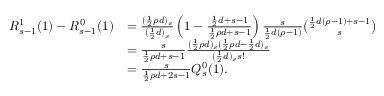Convert formula to latex. <formula><loc_0><loc_0><loc_500><loc_500>\begin{array} { r l } { R _ { s - 1 } ^ { 1 } ( 1 ) - R _ { s - 1 } ^ { 0 } ( 1 ) } & { = \frac { ( \frac { 1 } { 2 } \rho d ) _ { s } } { ( \frac { 1 } { 2 } d ) _ { s } } \left ( 1 - \frac { \frac { 1 } { 2 } d + s - 1 } { \frac { 1 } { 2 } \rho d + s - 1 } \right ) \frac { s } { \frac { 1 } { 2 } d ( \rho - 1 ) } \binom { \frac { 1 } { 2 } d ( \rho - 1 ) + s - 1 } { s } } \\ & { = \frac { s } { \frac { 1 } { 2 } \rho d + s - 1 } \frac { ( \frac { 1 } { 2 } \rho d ) _ { s } ( \frac { 1 } { 2 } \rho d - \frac { 1 } { 2 } d ) _ { s } } { ( \frac { 1 } { 2 } d ) _ { s } s ! } } \\ & { = \frac { s } { \frac { 1 } { 2 } \rho d + 2 s - 1 } Q _ { s } ^ { 0 } ( 1 ) . } \end{array}</formula> 